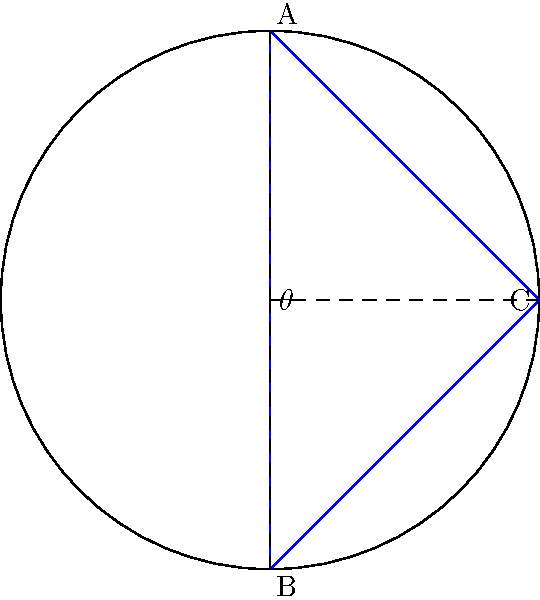In a hyperbolic model of a traffic-calmed street, the curvature of space is represented by the Poincaré disk model shown above. If the angle $\theta$ at the center of the disk is 90°, what is the sum of the interior angles of triangle ABC in this non-Euclidean geometry? To solve this problem, we need to follow these steps:

1) In hyperbolic geometry, the sum of the interior angles of a triangle is always less than 180°.

2) The defect of a hyperbolic triangle is defined as the difference between 180° and the sum of its interior angles. This defect is directly proportional to the area of the triangle.

3) In the Poincaré disk model, the defect is equal to the area of the triangle in the hyperbolic plane.

4) The area of a hyperbolic triangle with angles $\alpha$, $\beta$, and $\gamma$ is given by the formula:

   $$A = \pi - (\alpha + \beta + \gamma)$$

5) In this case, we're given that the central angle $\theta$ is 90°. In the Poincaré disk model, this corresponds to a triangle that covers a quarter of the disk.

6) The total area of the Poincaré disk represents 360° in the hyperbolic plane. Therefore, a quarter of the disk represents 90°.

7) Using the area formula:

   $$90° = \pi - (\alpha + \beta + \gamma)$$

8) Solving for the sum of the angles:

   $$\alpha + \beta + \gamma = \pi - 90° = 180° - 90° = 90°$$

Therefore, the sum of the interior angles of triangle ABC in this hyperbolic model is 90°.
Answer: 90° 